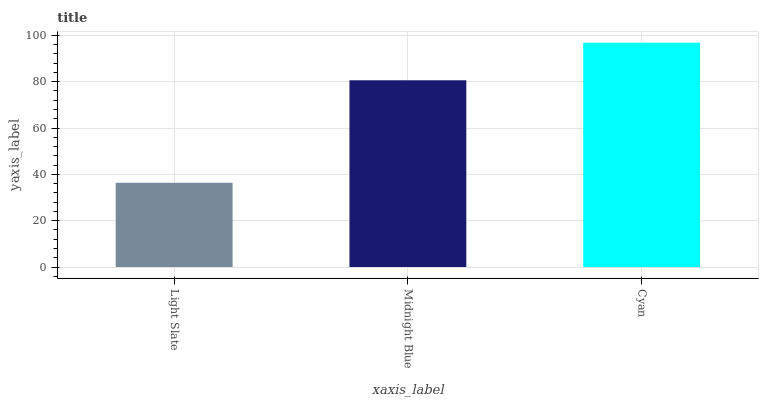Is Light Slate the minimum?
Answer yes or no. Yes. Is Cyan the maximum?
Answer yes or no. Yes. Is Midnight Blue the minimum?
Answer yes or no. No. Is Midnight Blue the maximum?
Answer yes or no. No. Is Midnight Blue greater than Light Slate?
Answer yes or no. Yes. Is Light Slate less than Midnight Blue?
Answer yes or no. Yes. Is Light Slate greater than Midnight Blue?
Answer yes or no. No. Is Midnight Blue less than Light Slate?
Answer yes or no. No. Is Midnight Blue the high median?
Answer yes or no. Yes. Is Midnight Blue the low median?
Answer yes or no. Yes. Is Light Slate the high median?
Answer yes or no. No. Is Cyan the low median?
Answer yes or no. No. 